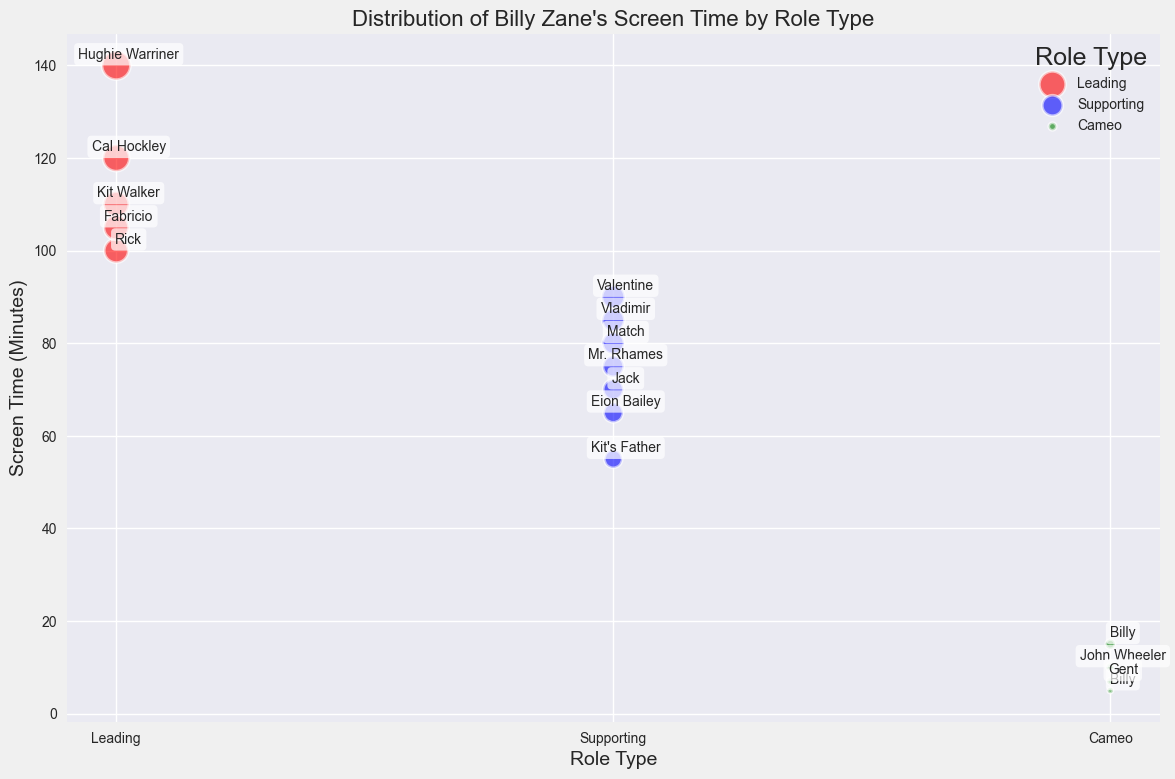Which role has the highest screen time among leading roles? To determine this, look at the red bubbles representing leading roles and identify the largest bubble, indicating the highest screen time. The largest red bubble corresponds to Hughie Warriner in "Head Above Water" with 140 minutes.
Answer: Hughie Warriner Which role type has the most variability in screen time? To find the role type with the most variability, observe the spread of bubbles vertically within each role type category. The wide range of screen times among the supporting roles (blue bubbles) indicates the highest variability from 55 to 90 minutes.
Answer: Supporting What is the combined screen time for all cameo roles? Sum the screen times of all green bubbles (cameo roles): 10 (John Wheeler) + 5 (Billy) + 15 (Billy) + 7 (Gent) = 37 minutes.
Answer: 37 minutes How many leading roles does Billy Zane have in the dataset? Count the number of red bubbles representing leading roles in the chart. There are 5 leading roles: Cal Hockley, Hughie Warriner, Kit Walker, Rick, and Fabricio.
Answer: 5 Which role type has the least total screen time? Sum the screen times for each role type and compare. Cameo (green) has the least total: 37 minutes, compared to leading and supporting roles.
Answer: Cameo What role has the highest screen time among supporting roles? Identify the highest blue bubble representing supporting roles; the largest is Valentine in "Dead Calm" with 90 minutes.
Answer: Valentine Is the screen time for the role "Cal Hockley" greater or lesser than "Kit Walker"? Compare the screen times of the red bubbles for Cal Hockley (120) and Kit Walker (110). Since 120 > 110, Cal Hockley has greater screen time.
Answer: Greater How much more screen time does the leading role with the least screen time have compared to the highest screen time in cameo roles? Identify the leading role with the least screen time, which is Rick with 100 minutes, and the highest screen time in cameo roles, which is Billy with 15 minutes. Calculate 100 - 15 = 85.
Answer: 85 minutes What is the average screen time for supporting roles? Sum the screen times of blue bubbles and divide by the number of supporting roles: (80 + 90 + 65 + 55 + 70 + 85 + 75) / 7 ≈ 74.28.
Answer: 74.28 